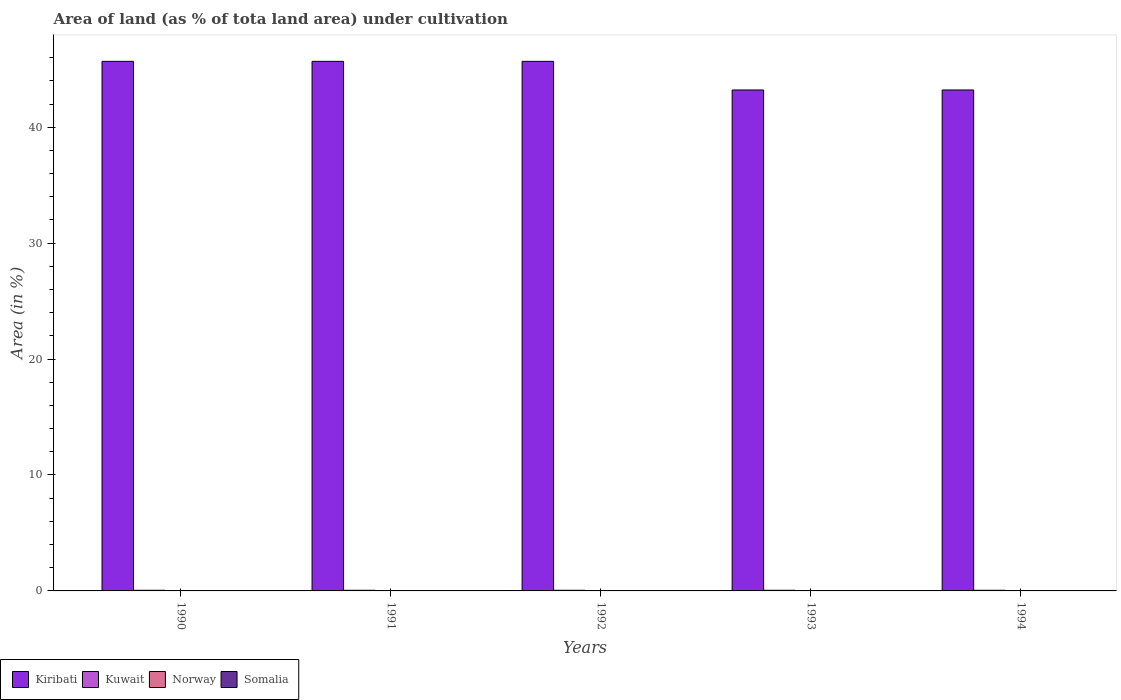How many different coloured bars are there?
Offer a terse response. 4. How many groups of bars are there?
Your answer should be compact. 5. How many bars are there on the 5th tick from the left?
Provide a succinct answer. 4. How many bars are there on the 1st tick from the right?
Offer a very short reply. 4. What is the percentage of land under cultivation in Norway in 1992?
Ensure brevity in your answer.  0.01. Across all years, what is the maximum percentage of land under cultivation in Kiribati?
Your answer should be compact. 45.68. Across all years, what is the minimum percentage of land under cultivation in Somalia?
Offer a very short reply. 0.03. In which year was the percentage of land under cultivation in Kiribati maximum?
Make the answer very short. 1990. In which year was the percentage of land under cultivation in Norway minimum?
Provide a short and direct response. 1990. What is the total percentage of land under cultivation in Kuwait in the graph?
Offer a terse response. 0.28. What is the difference between the percentage of land under cultivation in Norway in 1990 and that in 1994?
Offer a terse response. -0. What is the difference between the percentage of land under cultivation in Kiribati in 1992 and the percentage of land under cultivation in Norway in 1990?
Make the answer very short. 45.67. What is the average percentage of land under cultivation in Kuwait per year?
Offer a terse response. 0.06. In the year 1992, what is the difference between the percentage of land under cultivation in Norway and percentage of land under cultivation in Kiribati?
Make the answer very short. -45.67. In how many years, is the percentage of land under cultivation in Somalia greater than 2 %?
Make the answer very short. 0. Is the percentage of land under cultivation in Somalia in 1993 less than that in 1994?
Keep it short and to the point. No. Is the difference between the percentage of land under cultivation in Norway in 1990 and 1993 greater than the difference between the percentage of land under cultivation in Kiribati in 1990 and 1993?
Your answer should be compact. No. What is the difference between the highest and the second highest percentage of land under cultivation in Kiribati?
Offer a very short reply. 0. What is the difference between the highest and the lowest percentage of land under cultivation in Somalia?
Offer a terse response. 0. In how many years, is the percentage of land under cultivation in Norway greater than the average percentage of land under cultivation in Norway taken over all years?
Offer a terse response. 4. Is it the case that in every year, the sum of the percentage of land under cultivation in Somalia and percentage of land under cultivation in Kuwait is greater than the sum of percentage of land under cultivation in Kiribati and percentage of land under cultivation in Norway?
Make the answer very short. No. Is it the case that in every year, the sum of the percentage of land under cultivation in Kuwait and percentage of land under cultivation in Kiribati is greater than the percentage of land under cultivation in Norway?
Ensure brevity in your answer.  Yes. How many years are there in the graph?
Make the answer very short. 5. What is the difference between two consecutive major ticks on the Y-axis?
Provide a short and direct response. 10. Are the values on the major ticks of Y-axis written in scientific E-notation?
Offer a terse response. No. Where does the legend appear in the graph?
Your answer should be very brief. Bottom left. How many legend labels are there?
Your response must be concise. 4. What is the title of the graph?
Your answer should be very brief. Area of land (as % of tota land area) under cultivation. Does "Monaco" appear as one of the legend labels in the graph?
Ensure brevity in your answer.  No. What is the label or title of the X-axis?
Your answer should be compact. Years. What is the label or title of the Y-axis?
Make the answer very short. Area (in %). What is the Area (in %) in Kiribati in 1990?
Ensure brevity in your answer.  45.68. What is the Area (in %) in Kuwait in 1990?
Give a very brief answer. 0.06. What is the Area (in %) of Norway in 1990?
Keep it short and to the point. 0.01. What is the Area (in %) in Somalia in 1990?
Give a very brief answer. 0.03. What is the Area (in %) of Kiribati in 1991?
Make the answer very short. 45.68. What is the Area (in %) in Kuwait in 1991?
Make the answer very short. 0.06. What is the Area (in %) of Norway in 1991?
Give a very brief answer. 0.01. What is the Area (in %) of Somalia in 1991?
Your response must be concise. 0.03. What is the Area (in %) of Kiribati in 1992?
Provide a succinct answer. 45.68. What is the Area (in %) in Kuwait in 1992?
Provide a short and direct response. 0.06. What is the Area (in %) of Norway in 1992?
Offer a very short reply. 0.01. What is the Area (in %) in Somalia in 1992?
Keep it short and to the point. 0.03. What is the Area (in %) in Kiribati in 1993?
Provide a short and direct response. 43.21. What is the Area (in %) of Kuwait in 1993?
Offer a very short reply. 0.06. What is the Area (in %) in Norway in 1993?
Your answer should be compact. 0.01. What is the Area (in %) in Somalia in 1993?
Make the answer very short. 0.03. What is the Area (in %) in Kiribati in 1994?
Give a very brief answer. 43.21. What is the Area (in %) in Kuwait in 1994?
Make the answer very short. 0.06. What is the Area (in %) of Norway in 1994?
Ensure brevity in your answer.  0.01. What is the Area (in %) of Somalia in 1994?
Make the answer very short. 0.03. Across all years, what is the maximum Area (in %) of Kiribati?
Make the answer very short. 45.68. Across all years, what is the maximum Area (in %) of Kuwait?
Provide a short and direct response. 0.06. Across all years, what is the maximum Area (in %) in Norway?
Your response must be concise. 0.01. Across all years, what is the maximum Area (in %) of Somalia?
Offer a terse response. 0.03. Across all years, what is the minimum Area (in %) of Kiribati?
Your answer should be compact. 43.21. Across all years, what is the minimum Area (in %) in Kuwait?
Your response must be concise. 0.06. Across all years, what is the minimum Area (in %) of Norway?
Make the answer very short. 0.01. Across all years, what is the minimum Area (in %) in Somalia?
Your response must be concise. 0.03. What is the total Area (in %) in Kiribati in the graph?
Make the answer very short. 223.46. What is the total Area (in %) of Kuwait in the graph?
Give a very brief answer. 0.28. What is the total Area (in %) of Norway in the graph?
Offer a very short reply. 0.07. What is the total Area (in %) of Somalia in the graph?
Your answer should be compact. 0.16. What is the difference between the Area (in %) of Kiribati in 1990 and that in 1991?
Your answer should be very brief. 0. What is the difference between the Area (in %) of Kuwait in 1990 and that in 1991?
Your answer should be compact. 0. What is the difference between the Area (in %) in Norway in 1990 and that in 1991?
Offer a terse response. -0. What is the difference between the Area (in %) in Somalia in 1990 and that in 1991?
Give a very brief answer. 0. What is the difference between the Area (in %) of Norway in 1990 and that in 1992?
Your answer should be very brief. -0. What is the difference between the Area (in %) of Kiribati in 1990 and that in 1993?
Make the answer very short. 2.47. What is the difference between the Area (in %) of Kuwait in 1990 and that in 1993?
Offer a very short reply. 0. What is the difference between the Area (in %) of Norway in 1990 and that in 1993?
Provide a succinct answer. -0. What is the difference between the Area (in %) in Kiribati in 1990 and that in 1994?
Provide a short and direct response. 2.47. What is the difference between the Area (in %) in Norway in 1990 and that in 1994?
Provide a succinct answer. -0. What is the difference between the Area (in %) of Somalia in 1990 and that in 1994?
Make the answer very short. 0. What is the difference between the Area (in %) of Kuwait in 1991 and that in 1992?
Your answer should be compact. 0. What is the difference between the Area (in %) in Norway in 1991 and that in 1992?
Keep it short and to the point. 0. What is the difference between the Area (in %) of Kiribati in 1991 and that in 1993?
Offer a terse response. 2.47. What is the difference between the Area (in %) in Kuwait in 1991 and that in 1993?
Offer a terse response. 0. What is the difference between the Area (in %) of Kiribati in 1991 and that in 1994?
Offer a very short reply. 2.47. What is the difference between the Area (in %) in Kuwait in 1991 and that in 1994?
Your answer should be compact. 0. What is the difference between the Area (in %) of Norway in 1991 and that in 1994?
Ensure brevity in your answer.  0. What is the difference between the Area (in %) in Somalia in 1991 and that in 1994?
Ensure brevity in your answer.  0. What is the difference between the Area (in %) in Kiribati in 1992 and that in 1993?
Your response must be concise. 2.47. What is the difference between the Area (in %) in Kuwait in 1992 and that in 1993?
Provide a short and direct response. 0. What is the difference between the Area (in %) of Norway in 1992 and that in 1993?
Your answer should be very brief. 0. What is the difference between the Area (in %) in Kiribati in 1992 and that in 1994?
Provide a succinct answer. 2.47. What is the difference between the Area (in %) of Kuwait in 1992 and that in 1994?
Offer a terse response. 0. What is the difference between the Area (in %) of Norway in 1992 and that in 1994?
Your response must be concise. 0. What is the difference between the Area (in %) in Somalia in 1992 and that in 1994?
Give a very brief answer. 0. What is the difference between the Area (in %) of Norway in 1993 and that in 1994?
Your answer should be compact. 0. What is the difference between the Area (in %) of Somalia in 1993 and that in 1994?
Make the answer very short. 0. What is the difference between the Area (in %) in Kiribati in 1990 and the Area (in %) in Kuwait in 1991?
Your answer should be compact. 45.62. What is the difference between the Area (in %) of Kiribati in 1990 and the Area (in %) of Norway in 1991?
Make the answer very short. 45.67. What is the difference between the Area (in %) in Kiribati in 1990 and the Area (in %) in Somalia in 1991?
Provide a short and direct response. 45.65. What is the difference between the Area (in %) in Kuwait in 1990 and the Area (in %) in Norway in 1991?
Offer a terse response. 0.04. What is the difference between the Area (in %) of Kuwait in 1990 and the Area (in %) of Somalia in 1991?
Offer a terse response. 0.02. What is the difference between the Area (in %) of Norway in 1990 and the Area (in %) of Somalia in 1991?
Your response must be concise. -0.02. What is the difference between the Area (in %) of Kiribati in 1990 and the Area (in %) of Kuwait in 1992?
Your response must be concise. 45.62. What is the difference between the Area (in %) in Kiribati in 1990 and the Area (in %) in Norway in 1992?
Your answer should be compact. 45.67. What is the difference between the Area (in %) of Kiribati in 1990 and the Area (in %) of Somalia in 1992?
Offer a terse response. 45.65. What is the difference between the Area (in %) of Kuwait in 1990 and the Area (in %) of Norway in 1992?
Provide a succinct answer. 0.04. What is the difference between the Area (in %) of Kuwait in 1990 and the Area (in %) of Somalia in 1992?
Keep it short and to the point. 0.02. What is the difference between the Area (in %) of Norway in 1990 and the Area (in %) of Somalia in 1992?
Your answer should be very brief. -0.02. What is the difference between the Area (in %) of Kiribati in 1990 and the Area (in %) of Kuwait in 1993?
Give a very brief answer. 45.62. What is the difference between the Area (in %) in Kiribati in 1990 and the Area (in %) in Norway in 1993?
Offer a very short reply. 45.67. What is the difference between the Area (in %) of Kiribati in 1990 and the Area (in %) of Somalia in 1993?
Make the answer very short. 45.65. What is the difference between the Area (in %) of Kuwait in 1990 and the Area (in %) of Norway in 1993?
Keep it short and to the point. 0.04. What is the difference between the Area (in %) of Kuwait in 1990 and the Area (in %) of Somalia in 1993?
Your response must be concise. 0.02. What is the difference between the Area (in %) of Norway in 1990 and the Area (in %) of Somalia in 1993?
Make the answer very short. -0.02. What is the difference between the Area (in %) of Kiribati in 1990 and the Area (in %) of Kuwait in 1994?
Your answer should be compact. 45.62. What is the difference between the Area (in %) in Kiribati in 1990 and the Area (in %) in Norway in 1994?
Make the answer very short. 45.67. What is the difference between the Area (in %) in Kiribati in 1990 and the Area (in %) in Somalia in 1994?
Provide a succinct answer. 45.65. What is the difference between the Area (in %) in Kuwait in 1990 and the Area (in %) in Norway in 1994?
Offer a terse response. 0.04. What is the difference between the Area (in %) of Kuwait in 1990 and the Area (in %) of Somalia in 1994?
Give a very brief answer. 0.02. What is the difference between the Area (in %) of Norway in 1990 and the Area (in %) of Somalia in 1994?
Keep it short and to the point. -0.02. What is the difference between the Area (in %) in Kiribati in 1991 and the Area (in %) in Kuwait in 1992?
Your answer should be compact. 45.62. What is the difference between the Area (in %) of Kiribati in 1991 and the Area (in %) of Norway in 1992?
Provide a succinct answer. 45.67. What is the difference between the Area (in %) in Kiribati in 1991 and the Area (in %) in Somalia in 1992?
Your response must be concise. 45.65. What is the difference between the Area (in %) in Kuwait in 1991 and the Area (in %) in Norway in 1992?
Offer a very short reply. 0.04. What is the difference between the Area (in %) in Kuwait in 1991 and the Area (in %) in Somalia in 1992?
Your response must be concise. 0.02. What is the difference between the Area (in %) of Norway in 1991 and the Area (in %) of Somalia in 1992?
Your answer should be very brief. -0.02. What is the difference between the Area (in %) of Kiribati in 1991 and the Area (in %) of Kuwait in 1993?
Ensure brevity in your answer.  45.62. What is the difference between the Area (in %) in Kiribati in 1991 and the Area (in %) in Norway in 1993?
Your response must be concise. 45.67. What is the difference between the Area (in %) in Kiribati in 1991 and the Area (in %) in Somalia in 1993?
Keep it short and to the point. 45.65. What is the difference between the Area (in %) in Kuwait in 1991 and the Area (in %) in Norway in 1993?
Provide a short and direct response. 0.04. What is the difference between the Area (in %) in Kuwait in 1991 and the Area (in %) in Somalia in 1993?
Give a very brief answer. 0.02. What is the difference between the Area (in %) in Norway in 1991 and the Area (in %) in Somalia in 1993?
Offer a very short reply. -0.02. What is the difference between the Area (in %) of Kiribati in 1991 and the Area (in %) of Kuwait in 1994?
Provide a succinct answer. 45.62. What is the difference between the Area (in %) of Kiribati in 1991 and the Area (in %) of Norway in 1994?
Provide a succinct answer. 45.67. What is the difference between the Area (in %) in Kiribati in 1991 and the Area (in %) in Somalia in 1994?
Make the answer very short. 45.65. What is the difference between the Area (in %) of Kuwait in 1991 and the Area (in %) of Norway in 1994?
Your answer should be compact. 0.04. What is the difference between the Area (in %) of Kuwait in 1991 and the Area (in %) of Somalia in 1994?
Make the answer very short. 0.02. What is the difference between the Area (in %) of Norway in 1991 and the Area (in %) of Somalia in 1994?
Make the answer very short. -0.02. What is the difference between the Area (in %) in Kiribati in 1992 and the Area (in %) in Kuwait in 1993?
Ensure brevity in your answer.  45.62. What is the difference between the Area (in %) of Kiribati in 1992 and the Area (in %) of Norway in 1993?
Offer a terse response. 45.67. What is the difference between the Area (in %) of Kiribati in 1992 and the Area (in %) of Somalia in 1993?
Your response must be concise. 45.65. What is the difference between the Area (in %) in Kuwait in 1992 and the Area (in %) in Norway in 1993?
Ensure brevity in your answer.  0.04. What is the difference between the Area (in %) in Kuwait in 1992 and the Area (in %) in Somalia in 1993?
Give a very brief answer. 0.02. What is the difference between the Area (in %) in Norway in 1992 and the Area (in %) in Somalia in 1993?
Your response must be concise. -0.02. What is the difference between the Area (in %) of Kiribati in 1992 and the Area (in %) of Kuwait in 1994?
Ensure brevity in your answer.  45.62. What is the difference between the Area (in %) of Kiribati in 1992 and the Area (in %) of Norway in 1994?
Offer a very short reply. 45.67. What is the difference between the Area (in %) in Kiribati in 1992 and the Area (in %) in Somalia in 1994?
Ensure brevity in your answer.  45.65. What is the difference between the Area (in %) in Kuwait in 1992 and the Area (in %) in Norway in 1994?
Make the answer very short. 0.04. What is the difference between the Area (in %) in Kuwait in 1992 and the Area (in %) in Somalia in 1994?
Your answer should be compact. 0.02. What is the difference between the Area (in %) of Norway in 1992 and the Area (in %) of Somalia in 1994?
Offer a terse response. -0.02. What is the difference between the Area (in %) of Kiribati in 1993 and the Area (in %) of Kuwait in 1994?
Your response must be concise. 43.15. What is the difference between the Area (in %) in Kiribati in 1993 and the Area (in %) in Norway in 1994?
Keep it short and to the point. 43.2. What is the difference between the Area (in %) in Kiribati in 1993 and the Area (in %) in Somalia in 1994?
Your answer should be compact. 43.18. What is the difference between the Area (in %) of Kuwait in 1993 and the Area (in %) of Norway in 1994?
Offer a very short reply. 0.04. What is the difference between the Area (in %) of Kuwait in 1993 and the Area (in %) of Somalia in 1994?
Give a very brief answer. 0.02. What is the difference between the Area (in %) of Norway in 1993 and the Area (in %) of Somalia in 1994?
Your answer should be very brief. -0.02. What is the average Area (in %) in Kiribati per year?
Offer a very short reply. 44.69. What is the average Area (in %) in Kuwait per year?
Your answer should be compact. 0.06. What is the average Area (in %) in Norway per year?
Make the answer very short. 0.01. What is the average Area (in %) of Somalia per year?
Offer a terse response. 0.03. In the year 1990, what is the difference between the Area (in %) in Kiribati and Area (in %) in Kuwait?
Keep it short and to the point. 45.62. In the year 1990, what is the difference between the Area (in %) in Kiribati and Area (in %) in Norway?
Give a very brief answer. 45.67. In the year 1990, what is the difference between the Area (in %) in Kiribati and Area (in %) in Somalia?
Your answer should be compact. 45.65. In the year 1990, what is the difference between the Area (in %) of Kuwait and Area (in %) of Norway?
Your response must be concise. 0.05. In the year 1990, what is the difference between the Area (in %) of Kuwait and Area (in %) of Somalia?
Offer a terse response. 0.02. In the year 1990, what is the difference between the Area (in %) in Norway and Area (in %) in Somalia?
Offer a very short reply. -0.02. In the year 1991, what is the difference between the Area (in %) in Kiribati and Area (in %) in Kuwait?
Your answer should be very brief. 45.62. In the year 1991, what is the difference between the Area (in %) of Kiribati and Area (in %) of Norway?
Provide a short and direct response. 45.67. In the year 1991, what is the difference between the Area (in %) in Kiribati and Area (in %) in Somalia?
Offer a very short reply. 45.65. In the year 1991, what is the difference between the Area (in %) of Kuwait and Area (in %) of Norway?
Offer a terse response. 0.04. In the year 1991, what is the difference between the Area (in %) in Kuwait and Area (in %) in Somalia?
Keep it short and to the point. 0.02. In the year 1991, what is the difference between the Area (in %) of Norway and Area (in %) of Somalia?
Your response must be concise. -0.02. In the year 1992, what is the difference between the Area (in %) in Kiribati and Area (in %) in Kuwait?
Ensure brevity in your answer.  45.62. In the year 1992, what is the difference between the Area (in %) of Kiribati and Area (in %) of Norway?
Your answer should be compact. 45.67. In the year 1992, what is the difference between the Area (in %) of Kiribati and Area (in %) of Somalia?
Keep it short and to the point. 45.65. In the year 1992, what is the difference between the Area (in %) in Kuwait and Area (in %) in Norway?
Make the answer very short. 0.04. In the year 1992, what is the difference between the Area (in %) of Kuwait and Area (in %) of Somalia?
Make the answer very short. 0.02. In the year 1992, what is the difference between the Area (in %) of Norway and Area (in %) of Somalia?
Your answer should be compact. -0.02. In the year 1993, what is the difference between the Area (in %) in Kiribati and Area (in %) in Kuwait?
Your answer should be compact. 43.15. In the year 1993, what is the difference between the Area (in %) in Kiribati and Area (in %) in Norway?
Give a very brief answer. 43.2. In the year 1993, what is the difference between the Area (in %) of Kiribati and Area (in %) of Somalia?
Offer a very short reply. 43.18. In the year 1993, what is the difference between the Area (in %) of Kuwait and Area (in %) of Norway?
Your answer should be very brief. 0.04. In the year 1993, what is the difference between the Area (in %) of Kuwait and Area (in %) of Somalia?
Provide a short and direct response. 0.02. In the year 1993, what is the difference between the Area (in %) of Norway and Area (in %) of Somalia?
Give a very brief answer. -0.02. In the year 1994, what is the difference between the Area (in %) of Kiribati and Area (in %) of Kuwait?
Give a very brief answer. 43.15. In the year 1994, what is the difference between the Area (in %) in Kiribati and Area (in %) in Norway?
Ensure brevity in your answer.  43.2. In the year 1994, what is the difference between the Area (in %) of Kiribati and Area (in %) of Somalia?
Offer a very short reply. 43.18. In the year 1994, what is the difference between the Area (in %) in Kuwait and Area (in %) in Norway?
Make the answer very short. 0.04. In the year 1994, what is the difference between the Area (in %) of Kuwait and Area (in %) of Somalia?
Offer a terse response. 0.02. In the year 1994, what is the difference between the Area (in %) of Norway and Area (in %) of Somalia?
Offer a very short reply. -0.02. What is the ratio of the Area (in %) in Kiribati in 1990 to that in 1991?
Give a very brief answer. 1. What is the ratio of the Area (in %) in Kiribati in 1990 to that in 1992?
Offer a very short reply. 1. What is the ratio of the Area (in %) of Norway in 1990 to that in 1992?
Your answer should be very brief. 0.8. What is the ratio of the Area (in %) of Somalia in 1990 to that in 1992?
Offer a very short reply. 1. What is the ratio of the Area (in %) in Kiribati in 1990 to that in 1993?
Provide a short and direct response. 1.06. What is the ratio of the Area (in %) of Kiribati in 1990 to that in 1994?
Your answer should be very brief. 1.06. What is the ratio of the Area (in %) of Kuwait in 1990 to that in 1994?
Give a very brief answer. 1. What is the ratio of the Area (in %) in Somalia in 1990 to that in 1994?
Offer a terse response. 1. What is the ratio of the Area (in %) of Kuwait in 1991 to that in 1992?
Offer a very short reply. 1. What is the ratio of the Area (in %) in Kiribati in 1991 to that in 1993?
Offer a terse response. 1.06. What is the ratio of the Area (in %) of Norway in 1991 to that in 1993?
Keep it short and to the point. 1. What is the ratio of the Area (in %) of Kiribati in 1991 to that in 1994?
Offer a very short reply. 1.06. What is the ratio of the Area (in %) of Norway in 1991 to that in 1994?
Keep it short and to the point. 1. What is the ratio of the Area (in %) of Kiribati in 1992 to that in 1993?
Offer a very short reply. 1.06. What is the ratio of the Area (in %) in Somalia in 1992 to that in 1993?
Offer a very short reply. 1. What is the ratio of the Area (in %) of Kiribati in 1992 to that in 1994?
Make the answer very short. 1.06. What is the ratio of the Area (in %) in Kuwait in 1992 to that in 1994?
Your response must be concise. 1. What is the ratio of the Area (in %) of Norway in 1992 to that in 1994?
Offer a very short reply. 1. What is the ratio of the Area (in %) in Norway in 1993 to that in 1994?
Provide a succinct answer. 1. What is the ratio of the Area (in %) of Somalia in 1993 to that in 1994?
Provide a short and direct response. 1. What is the difference between the highest and the second highest Area (in %) in Norway?
Your answer should be compact. 0. What is the difference between the highest and the lowest Area (in %) in Kiribati?
Your answer should be very brief. 2.47. What is the difference between the highest and the lowest Area (in %) in Kuwait?
Provide a short and direct response. 0. What is the difference between the highest and the lowest Area (in %) in Norway?
Make the answer very short. 0. 